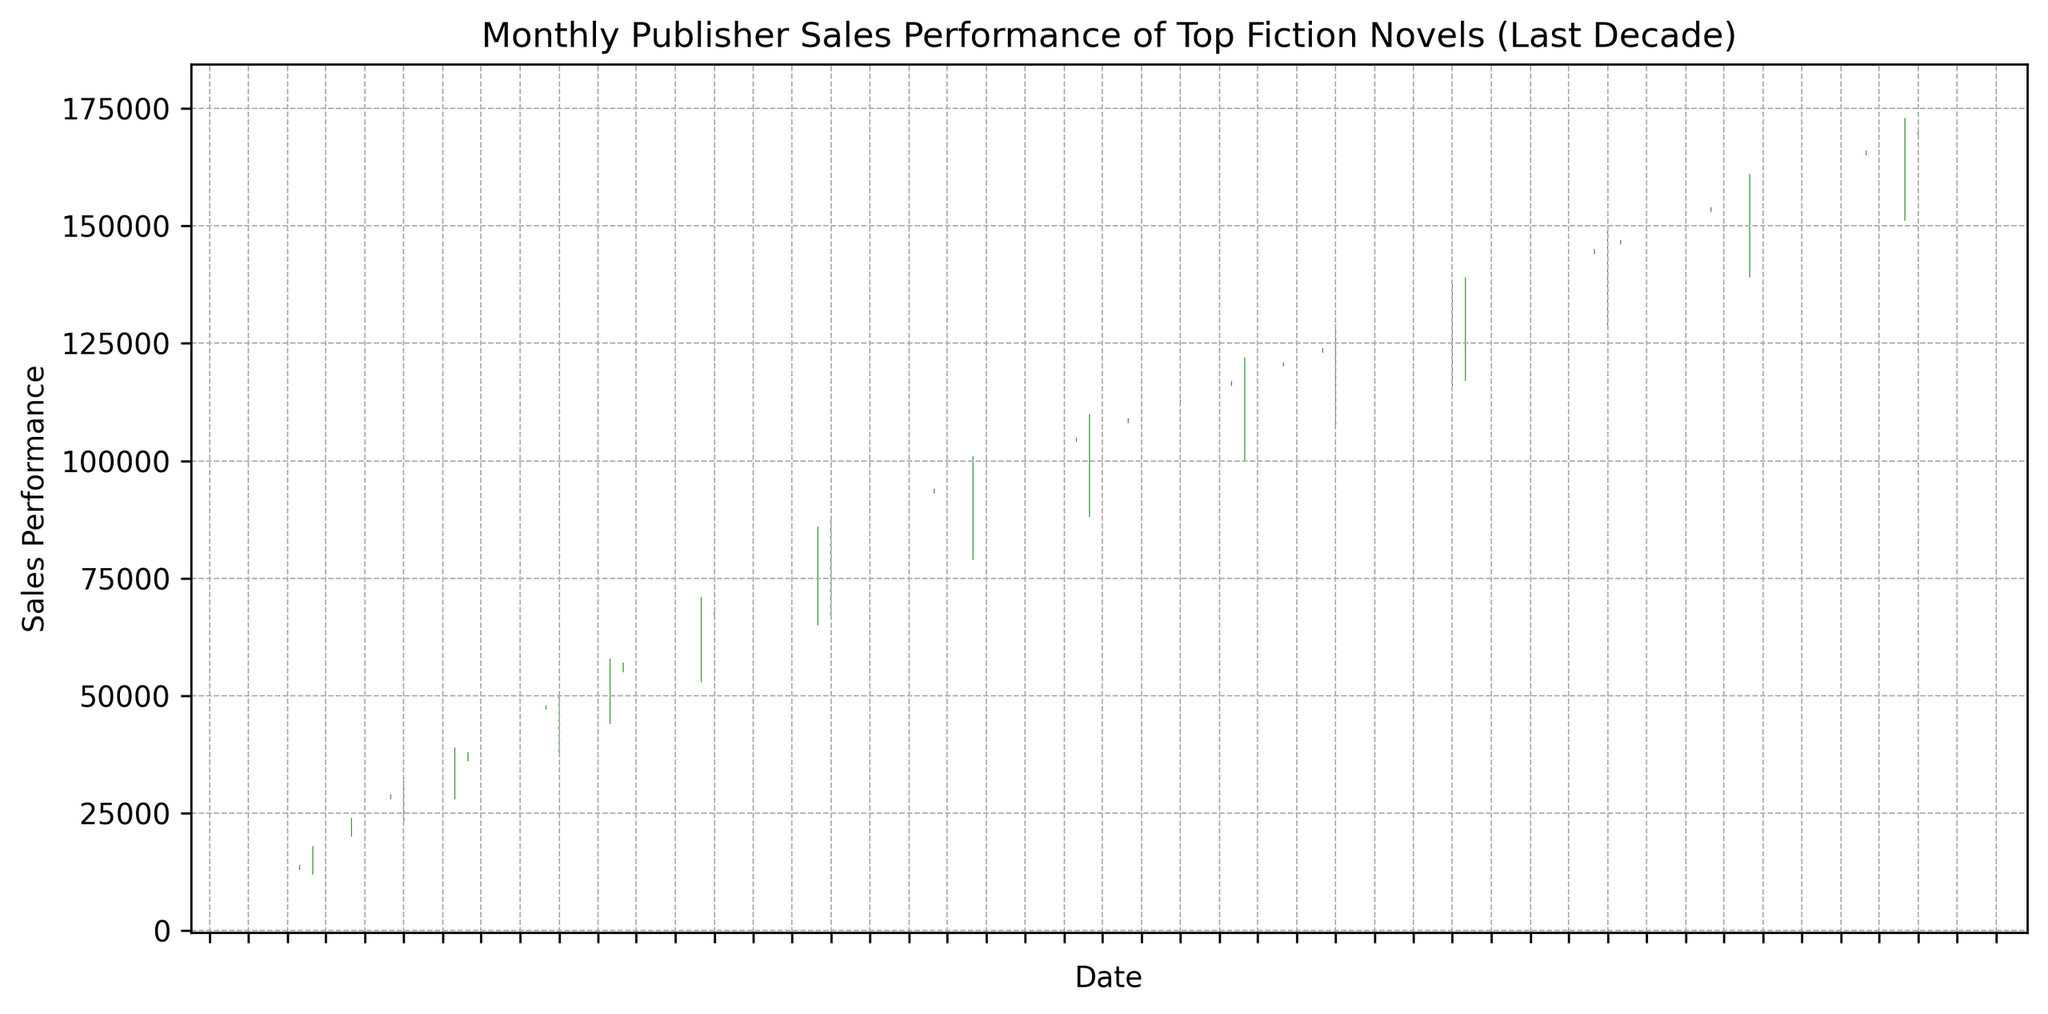What was the highest monthly sales performance and in which month did it occur? To find the highest monthly sales performance, we look for the maximum high value in the candlestick chart. The highest sales performance corresponds to the highest value in the High column. We see that the highest monthly sales of 176,000 occurred in October 2023.
Answer: 176,000 in October 2023 Which months showed a decrease in sales performance, and how are they visually represented on the chart? To identify months with a decrease in sales performance, we look for months where the close value is lower than the open value. These are represented by red candlesticks on the chart. By observing the figure, the months with decreases are those with red bars (e.g., if present).
Answer: Red candlesticks How many months in the last decade had a closing sales performance of at least 100,000? To answer this, we look for candlesticks where the Close value is 100,000 or more. Starting from July 2017, we can count the number of months. Observing the chart, there are several months that meet this criterion.
Answer: 76 months What is the trend in sales performance from the start to the end of the plotted period? To determine the trend, we compare the starting sales performance (open value of the first month in 2013) with the ending performance (close value of the last month in 2023). We can visually observe an upward trend as the initial values are much lower than the final values.
Answer: Upward trend Which month experienced the sharpest single-month increase in sales, and how much was the increase? To find the sharpest single-month increase, look for the month with the largest difference between close value and open value in positive terms. Checking the differences, we see that January 2014 had the highest difference (34,000 - 26,000 = 8,000).
Answer: January 2014, 8,000 By how much did the sales performance increase from January 2013 to January 2023? First, identify the close value for January 2013 (12,000) and January 2023 (163,000). Then calculate the increase: 163,000 - 12,000.
Answer: 151,000 In terms of visual attributes, how can you distinguish between months with positive and negative sales growth? Positive sales growth months are shown with green candlesticks, indicating the closing value is higher than the opening value. In contrast, negative growth months have red candlesticks, indicating the closing value is lower than the opening value.
Answer: Green candlesticks for positive, red candlesticks for negative How did the sales performance in July 2019 compare to July 2020? We compare the close values for July 2019 (121,000) and July 2020 (133,000). Visually, we can see that the close value in July 2020 is higher than in July 2019.
Answer: July 2020 is higher What is the average closing sales performance for the year 2018? To calculate this, sum up the close values for each month in 2018 and divide by 12. For 2018, the close values are 103,000, 104,000, 105,000, 106,000, 107,000, 108,000, 109,000, 110,000, 111,000, 112,000, 113,000, and 114,000. Summing these values gives 1,298,000. Dividing by 12: 1,298,000 / 12 = 108,167.
Answer: 108,167 